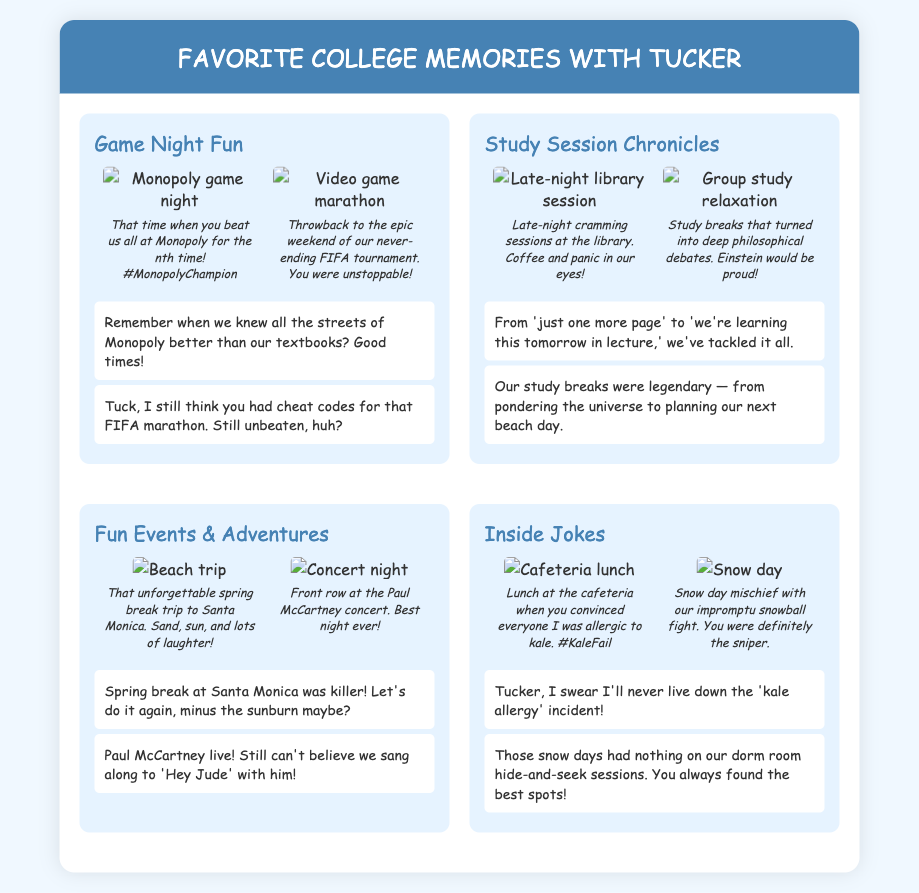What was Tucker's title during game night? Tucker was referred to as the #MonopolyChampion during the game night when he beat everyone at Monopoly.
Answer: #MonopolyChampion How many photos are in the "Game Night Fun" section? The "Game Night Fun" section contains two photos, one of a Monopoly game night and one of a FIFA tournament.
Answer: 2 What was the location of the memorable spring break trip? The unforgettable spring break trip was to Santa Monica, as mentioned in the photo caption.
Answer: Santa Monica Which concert did Tucker and the author attend? They attended the Paul McCartney concert, which is highlighted in one of the photo captions.
Answer: Paul McCartney What humorous incident is noted regarding lunch at the cafeteria? The humorous incident was when Tucker convinced everyone that the author was allergic to kale.
Answer: Kale Fail What was one of the topics discussed during study breaks? One of the topics discussed during study breaks was deep philosophical debates.
Answer: Deep philosophical debates Who was known as the sniper during the snow day mischief? Tucker was known as the sniper during their snowball fight on a snow day.
Answer: Tucker What type of study sessions did the author and Tucker have? The author and Tucker had late-night cramming sessions at the library for their studies.
Answer: Late-night cramming sessions 